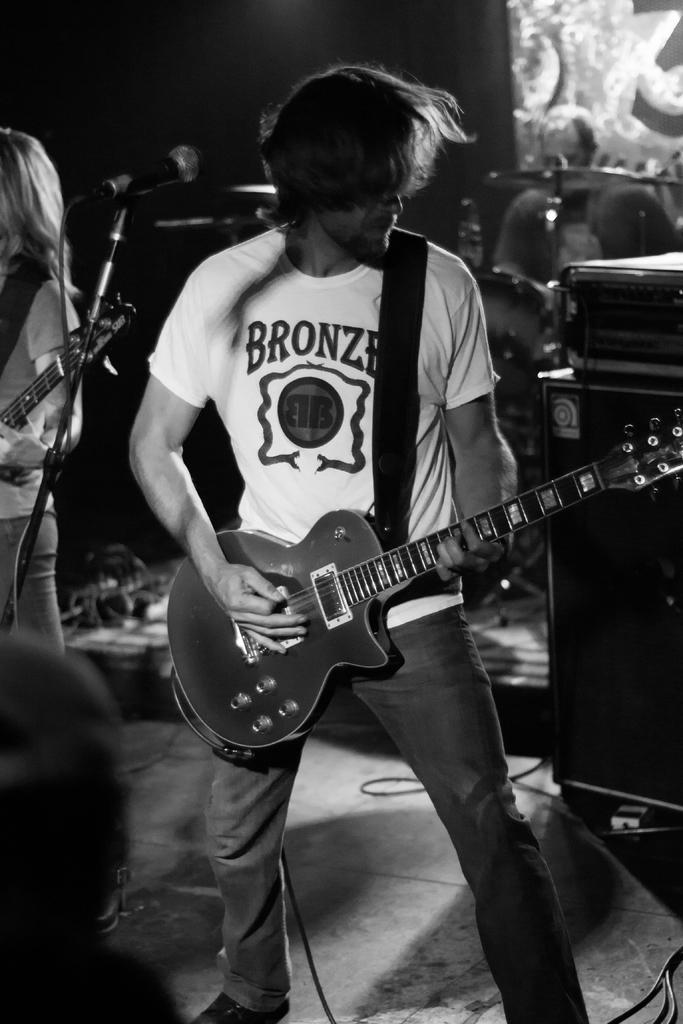Describe this image in one or two sentences. In the image we can see there is a man who is standing and he is playing a guitar and beside him there is a mike with a stand and beside it there is a woman who is standing holding a guitar and behind the person there are speakers and drums and a person sitting on it. 